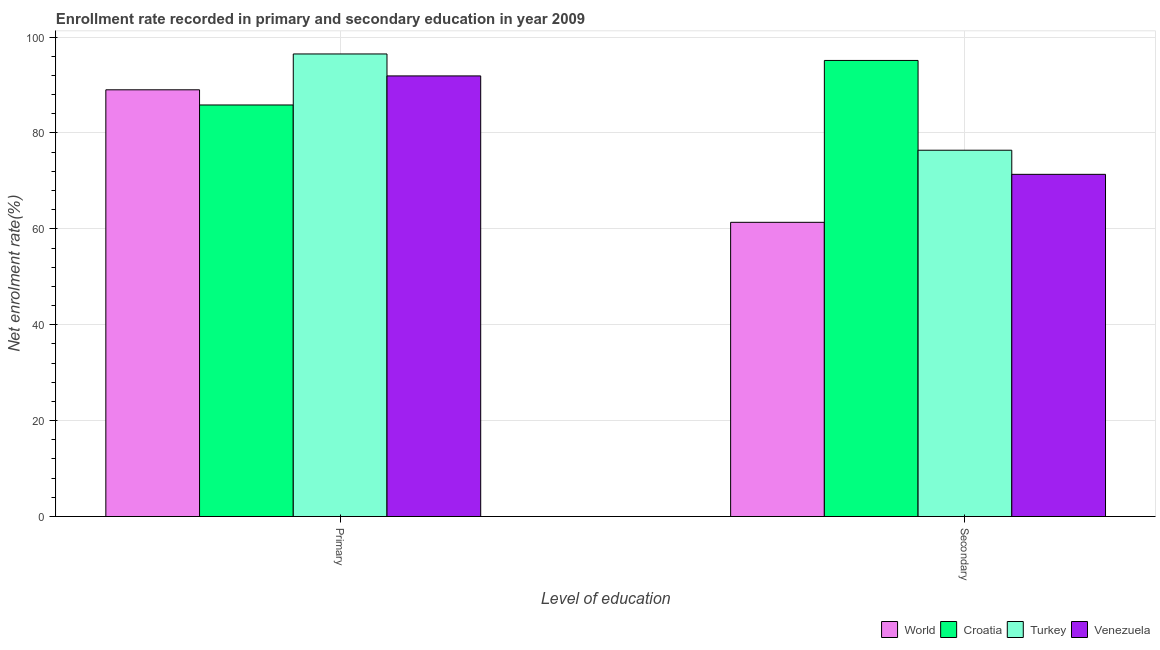How many groups of bars are there?
Your answer should be compact. 2. Are the number of bars per tick equal to the number of legend labels?
Provide a short and direct response. Yes. Are the number of bars on each tick of the X-axis equal?
Ensure brevity in your answer.  Yes. What is the label of the 1st group of bars from the left?
Ensure brevity in your answer.  Primary. What is the enrollment rate in primary education in World?
Give a very brief answer. 89.01. Across all countries, what is the maximum enrollment rate in primary education?
Your answer should be very brief. 96.49. Across all countries, what is the minimum enrollment rate in secondary education?
Your answer should be very brief. 61.37. In which country was the enrollment rate in secondary education maximum?
Ensure brevity in your answer.  Croatia. In which country was the enrollment rate in secondary education minimum?
Your response must be concise. World. What is the total enrollment rate in primary education in the graph?
Your answer should be very brief. 363.24. What is the difference between the enrollment rate in primary education in Croatia and that in Venezuela?
Provide a succinct answer. -6.06. What is the difference between the enrollment rate in primary education in Turkey and the enrollment rate in secondary education in Croatia?
Offer a very short reply. 1.35. What is the average enrollment rate in secondary education per country?
Make the answer very short. 76.07. What is the difference between the enrollment rate in primary education and enrollment rate in secondary education in Venezuela?
Make the answer very short. 20.53. In how many countries, is the enrollment rate in primary education greater than 68 %?
Keep it short and to the point. 4. What is the ratio of the enrollment rate in primary education in Croatia to that in World?
Your answer should be compact. 0.96. Is the enrollment rate in secondary education in Turkey less than that in Venezuela?
Make the answer very short. No. What does the 1st bar from the left in Secondary represents?
Your answer should be very brief. World. What does the 1st bar from the right in Secondary represents?
Ensure brevity in your answer.  Venezuela. How many bars are there?
Ensure brevity in your answer.  8. Are all the bars in the graph horizontal?
Offer a terse response. No. How many countries are there in the graph?
Your answer should be very brief. 4. Does the graph contain any zero values?
Your response must be concise. No. Does the graph contain grids?
Keep it short and to the point. Yes. How many legend labels are there?
Your answer should be compact. 4. What is the title of the graph?
Provide a short and direct response. Enrollment rate recorded in primary and secondary education in year 2009. Does "Cameroon" appear as one of the legend labels in the graph?
Offer a very short reply. No. What is the label or title of the X-axis?
Keep it short and to the point. Level of education. What is the label or title of the Y-axis?
Ensure brevity in your answer.  Net enrolment rate(%). What is the Net enrolment rate(%) of World in Primary?
Your answer should be very brief. 89.01. What is the Net enrolment rate(%) of Croatia in Primary?
Your answer should be very brief. 85.84. What is the Net enrolment rate(%) of Turkey in Primary?
Your response must be concise. 96.49. What is the Net enrolment rate(%) of Venezuela in Primary?
Make the answer very short. 91.91. What is the Net enrolment rate(%) in World in Secondary?
Offer a terse response. 61.37. What is the Net enrolment rate(%) of Croatia in Secondary?
Give a very brief answer. 95.13. What is the Net enrolment rate(%) of Turkey in Secondary?
Give a very brief answer. 76.41. What is the Net enrolment rate(%) in Venezuela in Secondary?
Your answer should be very brief. 71.38. Across all Level of education, what is the maximum Net enrolment rate(%) in World?
Provide a succinct answer. 89.01. Across all Level of education, what is the maximum Net enrolment rate(%) of Croatia?
Provide a short and direct response. 95.13. Across all Level of education, what is the maximum Net enrolment rate(%) in Turkey?
Keep it short and to the point. 96.49. Across all Level of education, what is the maximum Net enrolment rate(%) of Venezuela?
Your answer should be very brief. 91.91. Across all Level of education, what is the minimum Net enrolment rate(%) of World?
Your answer should be very brief. 61.37. Across all Level of education, what is the minimum Net enrolment rate(%) of Croatia?
Offer a very short reply. 85.84. Across all Level of education, what is the minimum Net enrolment rate(%) in Turkey?
Offer a terse response. 76.41. Across all Level of education, what is the minimum Net enrolment rate(%) in Venezuela?
Offer a very short reply. 71.38. What is the total Net enrolment rate(%) in World in the graph?
Give a very brief answer. 150.38. What is the total Net enrolment rate(%) in Croatia in the graph?
Make the answer very short. 180.97. What is the total Net enrolment rate(%) of Turkey in the graph?
Ensure brevity in your answer.  172.89. What is the total Net enrolment rate(%) in Venezuela in the graph?
Make the answer very short. 163.28. What is the difference between the Net enrolment rate(%) of World in Primary and that in Secondary?
Offer a very short reply. 27.64. What is the difference between the Net enrolment rate(%) in Croatia in Primary and that in Secondary?
Make the answer very short. -9.29. What is the difference between the Net enrolment rate(%) of Turkey in Primary and that in Secondary?
Offer a terse response. 20.08. What is the difference between the Net enrolment rate(%) in Venezuela in Primary and that in Secondary?
Your answer should be compact. 20.53. What is the difference between the Net enrolment rate(%) in World in Primary and the Net enrolment rate(%) in Croatia in Secondary?
Your response must be concise. -6.12. What is the difference between the Net enrolment rate(%) in World in Primary and the Net enrolment rate(%) in Turkey in Secondary?
Provide a succinct answer. 12.6. What is the difference between the Net enrolment rate(%) in World in Primary and the Net enrolment rate(%) in Venezuela in Secondary?
Ensure brevity in your answer.  17.63. What is the difference between the Net enrolment rate(%) in Croatia in Primary and the Net enrolment rate(%) in Turkey in Secondary?
Provide a short and direct response. 9.44. What is the difference between the Net enrolment rate(%) in Croatia in Primary and the Net enrolment rate(%) in Venezuela in Secondary?
Offer a terse response. 14.47. What is the difference between the Net enrolment rate(%) in Turkey in Primary and the Net enrolment rate(%) in Venezuela in Secondary?
Offer a terse response. 25.11. What is the average Net enrolment rate(%) of World per Level of education?
Provide a succinct answer. 75.19. What is the average Net enrolment rate(%) in Croatia per Level of education?
Offer a terse response. 90.49. What is the average Net enrolment rate(%) in Turkey per Level of education?
Your answer should be compact. 86.45. What is the average Net enrolment rate(%) in Venezuela per Level of education?
Ensure brevity in your answer.  81.64. What is the difference between the Net enrolment rate(%) in World and Net enrolment rate(%) in Croatia in Primary?
Provide a short and direct response. 3.17. What is the difference between the Net enrolment rate(%) of World and Net enrolment rate(%) of Turkey in Primary?
Keep it short and to the point. -7.48. What is the difference between the Net enrolment rate(%) of World and Net enrolment rate(%) of Venezuela in Primary?
Provide a short and direct response. -2.9. What is the difference between the Net enrolment rate(%) of Croatia and Net enrolment rate(%) of Turkey in Primary?
Offer a very short reply. -10.64. What is the difference between the Net enrolment rate(%) in Croatia and Net enrolment rate(%) in Venezuela in Primary?
Ensure brevity in your answer.  -6.06. What is the difference between the Net enrolment rate(%) of Turkey and Net enrolment rate(%) of Venezuela in Primary?
Your response must be concise. 4.58. What is the difference between the Net enrolment rate(%) of World and Net enrolment rate(%) of Croatia in Secondary?
Your answer should be very brief. -33.76. What is the difference between the Net enrolment rate(%) of World and Net enrolment rate(%) of Turkey in Secondary?
Offer a terse response. -15.04. What is the difference between the Net enrolment rate(%) of World and Net enrolment rate(%) of Venezuela in Secondary?
Your answer should be compact. -10.01. What is the difference between the Net enrolment rate(%) of Croatia and Net enrolment rate(%) of Turkey in Secondary?
Your answer should be very brief. 18.73. What is the difference between the Net enrolment rate(%) of Croatia and Net enrolment rate(%) of Venezuela in Secondary?
Give a very brief answer. 23.76. What is the difference between the Net enrolment rate(%) in Turkey and Net enrolment rate(%) in Venezuela in Secondary?
Give a very brief answer. 5.03. What is the ratio of the Net enrolment rate(%) of World in Primary to that in Secondary?
Make the answer very short. 1.45. What is the ratio of the Net enrolment rate(%) of Croatia in Primary to that in Secondary?
Offer a very short reply. 0.9. What is the ratio of the Net enrolment rate(%) in Turkey in Primary to that in Secondary?
Your answer should be very brief. 1.26. What is the ratio of the Net enrolment rate(%) of Venezuela in Primary to that in Secondary?
Offer a very short reply. 1.29. What is the difference between the highest and the second highest Net enrolment rate(%) in World?
Provide a short and direct response. 27.64. What is the difference between the highest and the second highest Net enrolment rate(%) of Croatia?
Offer a terse response. 9.29. What is the difference between the highest and the second highest Net enrolment rate(%) of Turkey?
Provide a succinct answer. 20.08. What is the difference between the highest and the second highest Net enrolment rate(%) in Venezuela?
Provide a succinct answer. 20.53. What is the difference between the highest and the lowest Net enrolment rate(%) in World?
Make the answer very short. 27.64. What is the difference between the highest and the lowest Net enrolment rate(%) of Croatia?
Provide a succinct answer. 9.29. What is the difference between the highest and the lowest Net enrolment rate(%) in Turkey?
Provide a succinct answer. 20.08. What is the difference between the highest and the lowest Net enrolment rate(%) in Venezuela?
Your answer should be very brief. 20.53. 